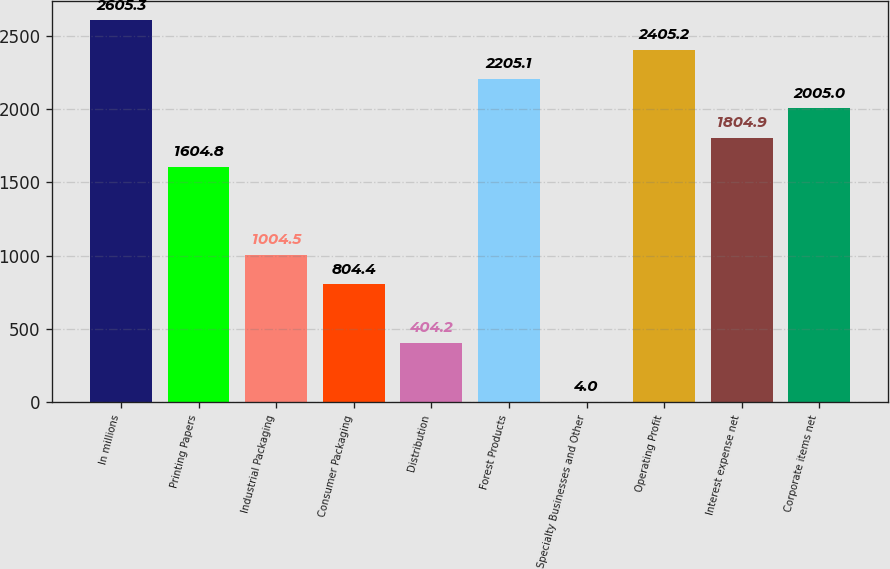<chart> <loc_0><loc_0><loc_500><loc_500><bar_chart><fcel>In millions<fcel>Printing Papers<fcel>Industrial Packaging<fcel>Consumer Packaging<fcel>Distribution<fcel>Forest Products<fcel>Specialty Businesses and Other<fcel>Operating Profit<fcel>Interest expense net<fcel>Corporate items net<nl><fcel>2605.3<fcel>1604.8<fcel>1004.5<fcel>804.4<fcel>404.2<fcel>2205.1<fcel>4<fcel>2405.2<fcel>1804.9<fcel>2005<nl></chart> 